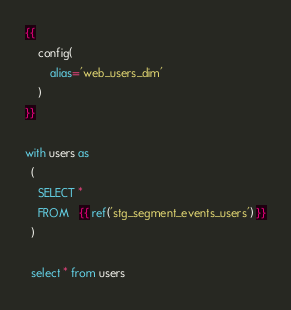Convert code to text. <code><loc_0><loc_0><loc_500><loc_500><_SQL_>{{
    config(
        alias='web_users_dim'
    )
}}

with users as
  (
    SELECT *
    FROM   {{ ref('stg_segment_events_users') }}
  )

  select * from users</code> 